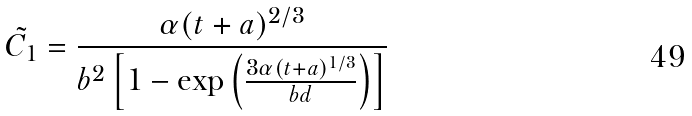<formula> <loc_0><loc_0><loc_500><loc_500>\tilde { C _ { 1 } } = \frac { \alpha ( t + a ) ^ { 2 / 3 } } { b ^ { 2 } \left [ 1 - \exp \left ( { \frac { 3 \alpha ( t + a ) ^ { 1 / 3 } } { b d } } \right ) \right ] }</formula> 